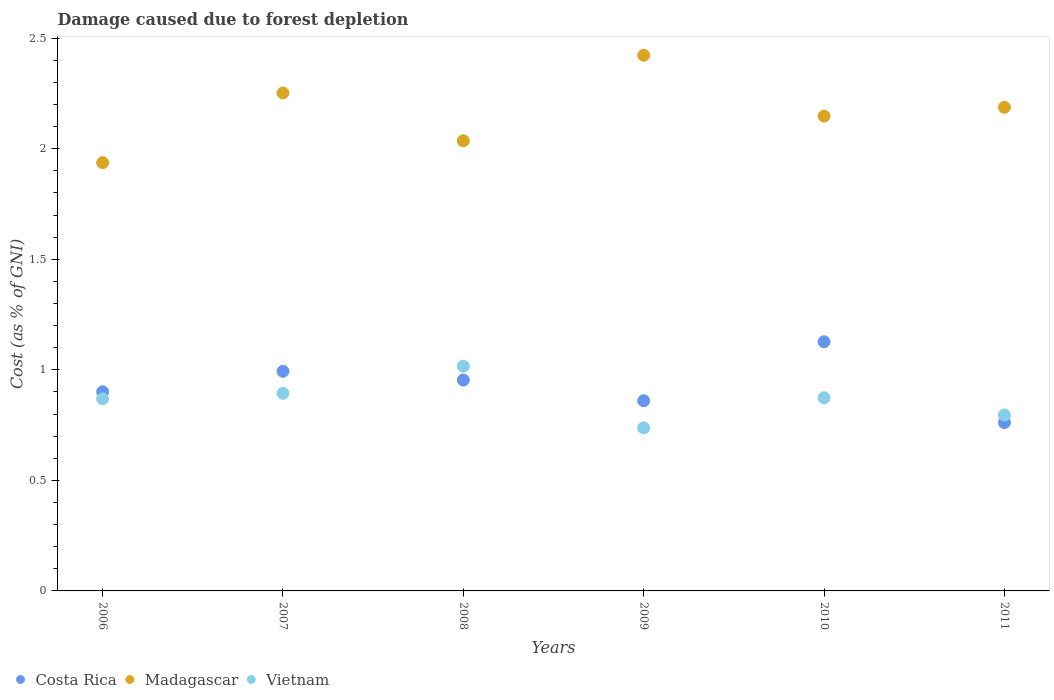Is the number of dotlines equal to the number of legend labels?
Ensure brevity in your answer.  Yes. What is the cost of damage caused due to forest depletion in Vietnam in 2011?
Your response must be concise. 0.8. Across all years, what is the maximum cost of damage caused due to forest depletion in Vietnam?
Provide a succinct answer. 1.02. Across all years, what is the minimum cost of damage caused due to forest depletion in Madagascar?
Provide a succinct answer. 1.94. In which year was the cost of damage caused due to forest depletion in Madagascar minimum?
Provide a short and direct response. 2006. What is the total cost of damage caused due to forest depletion in Costa Rica in the graph?
Provide a succinct answer. 5.6. What is the difference between the cost of damage caused due to forest depletion in Costa Rica in 2009 and that in 2011?
Your answer should be very brief. 0.1. What is the difference between the cost of damage caused due to forest depletion in Vietnam in 2006 and the cost of damage caused due to forest depletion in Costa Rica in 2010?
Ensure brevity in your answer.  -0.26. What is the average cost of damage caused due to forest depletion in Vietnam per year?
Give a very brief answer. 0.86. In the year 2006, what is the difference between the cost of damage caused due to forest depletion in Costa Rica and cost of damage caused due to forest depletion in Vietnam?
Give a very brief answer. 0.03. What is the ratio of the cost of damage caused due to forest depletion in Costa Rica in 2007 to that in 2011?
Offer a very short reply. 1.3. Is the difference between the cost of damage caused due to forest depletion in Costa Rica in 2007 and 2008 greater than the difference between the cost of damage caused due to forest depletion in Vietnam in 2007 and 2008?
Your answer should be very brief. Yes. What is the difference between the highest and the second highest cost of damage caused due to forest depletion in Madagascar?
Provide a short and direct response. 0.17. What is the difference between the highest and the lowest cost of damage caused due to forest depletion in Costa Rica?
Your response must be concise. 0.37. In how many years, is the cost of damage caused due to forest depletion in Madagascar greater than the average cost of damage caused due to forest depletion in Madagascar taken over all years?
Your answer should be compact. 3. Is the sum of the cost of damage caused due to forest depletion in Vietnam in 2007 and 2011 greater than the maximum cost of damage caused due to forest depletion in Madagascar across all years?
Offer a terse response. No. Is it the case that in every year, the sum of the cost of damage caused due to forest depletion in Madagascar and cost of damage caused due to forest depletion in Vietnam  is greater than the cost of damage caused due to forest depletion in Costa Rica?
Offer a very short reply. Yes. Is the cost of damage caused due to forest depletion in Vietnam strictly greater than the cost of damage caused due to forest depletion in Costa Rica over the years?
Offer a very short reply. No. How many years are there in the graph?
Provide a succinct answer. 6. Are the values on the major ticks of Y-axis written in scientific E-notation?
Ensure brevity in your answer.  No. Does the graph contain grids?
Offer a terse response. No. How many legend labels are there?
Ensure brevity in your answer.  3. How are the legend labels stacked?
Your response must be concise. Horizontal. What is the title of the graph?
Your response must be concise. Damage caused due to forest depletion. What is the label or title of the X-axis?
Provide a short and direct response. Years. What is the label or title of the Y-axis?
Give a very brief answer. Cost (as % of GNI). What is the Cost (as % of GNI) of Costa Rica in 2006?
Keep it short and to the point. 0.9. What is the Cost (as % of GNI) of Madagascar in 2006?
Ensure brevity in your answer.  1.94. What is the Cost (as % of GNI) in Vietnam in 2006?
Ensure brevity in your answer.  0.87. What is the Cost (as % of GNI) in Costa Rica in 2007?
Give a very brief answer. 0.99. What is the Cost (as % of GNI) of Madagascar in 2007?
Provide a succinct answer. 2.25. What is the Cost (as % of GNI) of Vietnam in 2007?
Ensure brevity in your answer.  0.89. What is the Cost (as % of GNI) of Costa Rica in 2008?
Provide a succinct answer. 0.95. What is the Cost (as % of GNI) in Madagascar in 2008?
Offer a terse response. 2.04. What is the Cost (as % of GNI) of Vietnam in 2008?
Offer a very short reply. 1.02. What is the Cost (as % of GNI) of Costa Rica in 2009?
Provide a short and direct response. 0.86. What is the Cost (as % of GNI) of Madagascar in 2009?
Provide a succinct answer. 2.42. What is the Cost (as % of GNI) of Vietnam in 2009?
Your response must be concise. 0.74. What is the Cost (as % of GNI) in Costa Rica in 2010?
Provide a succinct answer. 1.13. What is the Cost (as % of GNI) of Madagascar in 2010?
Provide a succinct answer. 2.15. What is the Cost (as % of GNI) of Vietnam in 2010?
Provide a short and direct response. 0.87. What is the Cost (as % of GNI) in Costa Rica in 2011?
Your response must be concise. 0.76. What is the Cost (as % of GNI) in Madagascar in 2011?
Give a very brief answer. 2.19. What is the Cost (as % of GNI) in Vietnam in 2011?
Give a very brief answer. 0.8. Across all years, what is the maximum Cost (as % of GNI) of Costa Rica?
Your answer should be very brief. 1.13. Across all years, what is the maximum Cost (as % of GNI) of Madagascar?
Your answer should be very brief. 2.42. Across all years, what is the maximum Cost (as % of GNI) in Vietnam?
Provide a short and direct response. 1.02. Across all years, what is the minimum Cost (as % of GNI) in Costa Rica?
Keep it short and to the point. 0.76. Across all years, what is the minimum Cost (as % of GNI) of Madagascar?
Offer a terse response. 1.94. Across all years, what is the minimum Cost (as % of GNI) of Vietnam?
Give a very brief answer. 0.74. What is the total Cost (as % of GNI) in Costa Rica in the graph?
Offer a terse response. 5.6. What is the total Cost (as % of GNI) in Madagascar in the graph?
Offer a very short reply. 12.98. What is the total Cost (as % of GNI) of Vietnam in the graph?
Your answer should be very brief. 5.19. What is the difference between the Cost (as % of GNI) of Costa Rica in 2006 and that in 2007?
Make the answer very short. -0.09. What is the difference between the Cost (as % of GNI) of Madagascar in 2006 and that in 2007?
Make the answer very short. -0.32. What is the difference between the Cost (as % of GNI) of Vietnam in 2006 and that in 2007?
Your answer should be compact. -0.03. What is the difference between the Cost (as % of GNI) in Costa Rica in 2006 and that in 2008?
Your response must be concise. -0.05. What is the difference between the Cost (as % of GNI) of Madagascar in 2006 and that in 2008?
Give a very brief answer. -0.1. What is the difference between the Cost (as % of GNI) in Vietnam in 2006 and that in 2008?
Give a very brief answer. -0.15. What is the difference between the Cost (as % of GNI) of Costa Rica in 2006 and that in 2009?
Give a very brief answer. 0.04. What is the difference between the Cost (as % of GNI) in Madagascar in 2006 and that in 2009?
Your answer should be very brief. -0.49. What is the difference between the Cost (as % of GNI) in Vietnam in 2006 and that in 2009?
Your answer should be very brief. 0.13. What is the difference between the Cost (as % of GNI) in Costa Rica in 2006 and that in 2010?
Offer a terse response. -0.23. What is the difference between the Cost (as % of GNI) in Madagascar in 2006 and that in 2010?
Offer a very short reply. -0.21. What is the difference between the Cost (as % of GNI) of Vietnam in 2006 and that in 2010?
Ensure brevity in your answer.  -0.01. What is the difference between the Cost (as % of GNI) of Costa Rica in 2006 and that in 2011?
Your answer should be very brief. 0.14. What is the difference between the Cost (as % of GNI) in Madagascar in 2006 and that in 2011?
Provide a succinct answer. -0.25. What is the difference between the Cost (as % of GNI) of Vietnam in 2006 and that in 2011?
Keep it short and to the point. 0.07. What is the difference between the Cost (as % of GNI) of Costa Rica in 2007 and that in 2008?
Provide a succinct answer. 0.04. What is the difference between the Cost (as % of GNI) of Madagascar in 2007 and that in 2008?
Your response must be concise. 0.22. What is the difference between the Cost (as % of GNI) in Vietnam in 2007 and that in 2008?
Provide a succinct answer. -0.12. What is the difference between the Cost (as % of GNI) in Costa Rica in 2007 and that in 2009?
Provide a succinct answer. 0.13. What is the difference between the Cost (as % of GNI) of Madagascar in 2007 and that in 2009?
Give a very brief answer. -0.17. What is the difference between the Cost (as % of GNI) in Vietnam in 2007 and that in 2009?
Your answer should be very brief. 0.16. What is the difference between the Cost (as % of GNI) in Costa Rica in 2007 and that in 2010?
Ensure brevity in your answer.  -0.13. What is the difference between the Cost (as % of GNI) in Madagascar in 2007 and that in 2010?
Your response must be concise. 0.11. What is the difference between the Cost (as % of GNI) in Vietnam in 2007 and that in 2010?
Your answer should be very brief. 0.02. What is the difference between the Cost (as % of GNI) of Costa Rica in 2007 and that in 2011?
Make the answer very short. 0.23. What is the difference between the Cost (as % of GNI) of Madagascar in 2007 and that in 2011?
Your answer should be very brief. 0.06. What is the difference between the Cost (as % of GNI) in Vietnam in 2007 and that in 2011?
Provide a succinct answer. 0.1. What is the difference between the Cost (as % of GNI) in Costa Rica in 2008 and that in 2009?
Make the answer very short. 0.09. What is the difference between the Cost (as % of GNI) of Madagascar in 2008 and that in 2009?
Your answer should be very brief. -0.39. What is the difference between the Cost (as % of GNI) of Vietnam in 2008 and that in 2009?
Keep it short and to the point. 0.28. What is the difference between the Cost (as % of GNI) in Costa Rica in 2008 and that in 2010?
Make the answer very short. -0.17. What is the difference between the Cost (as % of GNI) in Madagascar in 2008 and that in 2010?
Keep it short and to the point. -0.11. What is the difference between the Cost (as % of GNI) in Vietnam in 2008 and that in 2010?
Provide a succinct answer. 0.14. What is the difference between the Cost (as % of GNI) of Costa Rica in 2008 and that in 2011?
Your answer should be very brief. 0.19. What is the difference between the Cost (as % of GNI) in Madagascar in 2008 and that in 2011?
Your answer should be compact. -0.15. What is the difference between the Cost (as % of GNI) in Vietnam in 2008 and that in 2011?
Your response must be concise. 0.22. What is the difference between the Cost (as % of GNI) in Costa Rica in 2009 and that in 2010?
Offer a very short reply. -0.27. What is the difference between the Cost (as % of GNI) in Madagascar in 2009 and that in 2010?
Your answer should be very brief. 0.28. What is the difference between the Cost (as % of GNI) of Vietnam in 2009 and that in 2010?
Ensure brevity in your answer.  -0.14. What is the difference between the Cost (as % of GNI) of Costa Rica in 2009 and that in 2011?
Keep it short and to the point. 0.1. What is the difference between the Cost (as % of GNI) in Madagascar in 2009 and that in 2011?
Offer a very short reply. 0.24. What is the difference between the Cost (as % of GNI) in Vietnam in 2009 and that in 2011?
Your response must be concise. -0.06. What is the difference between the Cost (as % of GNI) of Costa Rica in 2010 and that in 2011?
Make the answer very short. 0.37. What is the difference between the Cost (as % of GNI) in Madagascar in 2010 and that in 2011?
Your answer should be very brief. -0.04. What is the difference between the Cost (as % of GNI) in Vietnam in 2010 and that in 2011?
Provide a succinct answer. 0.08. What is the difference between the Cost (as % of GNI) of Costa Rica in 2006 and the Cost (as % of GNI) of Madagascar in 2007?
Keep it short and to the point. -1.35. What is the difference between the Cost (as % of GNI) of Costa Rica in 2006 and the Cost (as % of GNI) of Vietnam in 2007?
Offer a very short reply. 0.01. What is the difference between the Cost (as % of GNI) in Madagascar in 2006 and the Cost (as % of GNI) in Vietnam in 2007?
Keep it short and to the point. 1.04. What is the difference between the Cost (as % of GNI) of Costa Rica in 2006 and the Cost (as % of GNI) of Madagascar in 2008?
Provide a succinct answer. -1.14. What is the difference between the Cost (as % of GNI) of Costa Rica in 2006 and the Cost (as % of GNI) of Vietnam in 2008?
Offer a terse response. -0.12. What is the difference between the Cost (as % of GNI) in Madagascar in 2006 and the Cost (as % of GNI) in Vietnam in 2008?
Offer a very short reply. 0.92. What is the difference between the Cost (as % of GNI) in Costa Rica in 2006 and the Cost (as % of GNI) in Madagascar in 2009?
Ensure brevity in your answer.  -1.52. What is the difference between the Cost (as % of GNI) in Costa Rica in 2006 and the Cost (as % of GNI) in Vietnam in 2009?
Your answer should be compact. 0.16. What is the difference between the Cost (as % of GNI) of Madagascar in 2006 and the Cost (as % of GNI) of Vietnam in 2009?
Ensure brevity in your answer.  1.2. What is the difference between the Cost (as % of GNI) of Costa Rica in 2006 and the Cost (as % of GNI) of Madagascar in 2010?
Keep it short and to the point. -1.25. What is the difference between the Cost (as % of GNI) of Costa Rica in 2006 and the Cost (as % of GNI) of Vietnam in 2010?
Provide a short and direct response. 0.03. What is the difference between the Cost (as % of GNI) of Madagascar in 2006 and the Cost (as % of GNI) of Vietnam in 2010?
Make the answer very short. 1.06. What is the difference between the Cost (as % of GNI) in Costa Rica in 2006 and the Cost (as % of GNI) in Madagascar in 2011?
Your answer should be very brief. -1.29. What is the difference between the Cost (as % of GNI) of Costa Rica in 2006 and the Cost (as % of GNI) of Vietnam in 2011?
Provide a succinct answer. 0.1. What is the difference between the Cost (as % of GNI) of Madagascar in 2006 and the Cost (as % of GNI) of Vietnam in 2011?
Offer a terse response. 1.14. What is the difference between the Cost (as % of GNI) of Costa Rica in 2007 and the Cost (as % of GNI) of Madagascar in 2008?
Provide a succinct answer. -1.04. What is the difference between the Cost (as % of GNI) of Costa Rica in 2007 and the Cost (as % of GNI) of Vietnam in 2008?
Provide a succinct answer. -0.02. What is the difference between the Cost (as % of GNI) in Madagascar in 2007 and the Cost (as % of GNI) in Vietnam in 2008?
Provide a short and direct response. 1.24. What is the difference between the Cost (as % of GNI) in Costa Rica in 2007 and the Cost (as % of GNI) in Madagascar in 2009?
Provide a short and direct response. -1.43. What is the difference between the Cost (as % of GNI) of Costa Rica in 2007 and the Cost (as % of GNI) of Vietnam in 2009?
Keep it short and to the point. 0.26. What is the difference between the Cost (as % of GNI) of Madagascar in 2007 and the Cost (as % of GNI) of Vietnam in 2009?
Make the answer very short. 1.51. What is the difference between the Cost (as % of GNI) in Costa Rica in 2007 and the Cost (as % of GNI) in Madagascar in 2010?
Make the answer very short. -1.15. What is the difference between the Cost (as % of GNI) in Costa Rica in 2007 and the Cost (as % of GNI) in Vietnam in 2010?
Your answer should be very brief. 0.12. What is the difference between the Cost (as % of GNI) in Madagascar in 2007 and the Cost (as % of GNI) in Vietnam in 2010?
Keep it short and to the point. 1.38. What is the difference between the Cost (as % of GNI) in Costa Rica in 2007 and the Cost (as % of GNI) in Madagascar in 2011?
Keep it short and to the point. -1.19. What is the difference between the Cost (as % of GNI) in Costa Rica in 2007 and the Cost (as % of GNI) in Vietnam in 2011?
Give a very brief answer. 0.2. What is the difference between the Cost (as % of GNI) of Madagascar in 2007 and the Cost (as % of GNI) of Vietnam in 2011?
Give a very brief answer. 1.46. What is the difference between the Cost (as % of GNI) of Costa Rica in 2008 and the Cost (as % of GNI) of Madagascar in 2009?
Keep it short and to the point. -1.47. What is the difference between the Cost (as % of GNI) in Costa Rica in 2008 and the Cost (as % of GNI) in Vietnam in 2009?
Keep it short and to the point. 0.22. What is the difference between the Cost (as % of GNI) of Madagascar in 2008 and the Cost (as % of GNI) of Vietnam in 2009?
Keep it short and to the point. 1.3. What is the difference between the Cost (as % of GNI) in Costa Rica in 2008 and the Cost (as % of GNI) in Madagascar in 2010?
Ensure brevity in your answer.  -1.19. What is the difference between the Cost (as % of GNI) of Costa Rica in 2008 and the Cost (as % of GNI) of Vietnam in 2010?
Your answer should be compact. 0.08. What is the difference between the Cost (as % of GNI) in Madagascar in 2008 and the Cost (as % of GNI) in Vietnam in 2010?
Your answer should be compact. 1.16. What is the difference between the Cost (as % of GNI) of Costa Rica in 2008 and the Cost (as % of GNI) of Madagascar in 2011?
Your answer should be compact. -1.23. What is the difference between the Cost (as % of GNI) of Costa Rica in 2008 and the Cost (as % of GNI) of Vietnam in 2011?
Provide a short and direct response. 0.16. What is the difference between the Cost (as % of GNI) in Madagascar in 2008 and the Cost (as % of GNI) in Vietnam in 2011?
Keep it short and to the point. 1.24. What is the difference between the Cost (as % of GNI) of Costa Rica in 2009 and the Cost (as % of GNI) of Madagascar in 2010?
Make the answer very short. -1.29. What is the difference between the Cost (as % of GNI) of Costa Rica in 2009 and the Cost (as % of GNI) of Vietnam in 2010?
Provide a succinct answer. -0.01. What is the difference between the Cost (as % of GNI) of Madagascar in 2009 and the Cost (as % of GNI) of Vietnam in 2010?
Your answer should be compact. 1.55. What is the difference between the Cost (as % of GNI) in Costa Rica in 2009 and the Cost (as % of GNI) in Madagascar in 2011?
Your answer should be very brief. -1.33. What is the difference between the Cost (as % of GNI) in Costa Rica in 2009 and the Cost (as % of GNI) in Vietnam in 2011?
Provide a succinct answer. 0.06. What is the difference between the Cost (as % of GNI) of Madagascar in 2009 and the Cost (as % of GNI) of Vietnam in 2011?
Your answer should be compact. 1.63. What is the difference between the Cost (as % of GNI) of Costa Rica in 2010 and the Cost (as % of GNI) of Madagascar in 2011?
Your answer should be compact. -1.06. What is the difference between the Cost (as % of GNI) in Costa Rica in 2010 and the Cost (as % of GNI) in Vietnam in 2011?
Give a very brief answer. 0.33. What is the difference between the Cost (as % of GNI) in Madagascar in 2010 and the Cost (as % of GNI) in Vietnam in 2011?
Ensure brevity in your answer.  1.35. What is the average Cost (as % of GNI) in Costa Rica per year?
Provide a short and direct response. 0.93. What is the average Cost (as % of GNI) in Madagascar per year?
Provide a succinct answer. 2.16. What is the average Cost (as % of GNI) of Vietnam per year?
Offer a very short reply. 0.86. In the year 2006, what is the difference between the Cost (as % of GNI) of Costa Rica and Cost (as % of GNI) of Madagascar?
Provide a short and direct response. -1.04. In the year 2006, what is the difference between the Cost (as % of GNI) in Costa Rica and Cost (as % of GNI) in Vietnam?
Provide a short and direct response. 0.03. In the year 2006, what is the difference between the Cost (as % of GNI) in Madagascar and Cost (as % of GNI) in Vietnam?
Offer a terse response. 1.07. In the year 2007, what is the difference between the Cost (as % of GNI) in Costa Rica and Cost (as % of GNI) in Madagascar?
Your response must be concise. -1.26. In the year 2007, what is the difference between the Cost (as % of GNI) in Costa Rica and Cost (as % of GNI) in Vietnam?
Your answer should be compact. 0.1. In the year 2007, what is the difference between the Cost (as % of GNI) of Madagascar and Cost (as % of GNI) of Vietnam?
Your answer should be compact. 1.36. In the year 2008, what is the difference between the Cost (as % of GNI) in Costa Rica and Cost (as % of GNI) in Madagascar?
Keep it short and to the point. -1.08. In the year 2008, what is the difference between the Cost (as % of GNI) in Costa Rica and Cost (as % of GNI) in Vietnam?
Your answer should be compact. -0.06. In the year 2008, what is the difference between the Cost (as % of GNI) of Madagascar and Cost (as % of GNI) of Vietnam?
Give a very brief answer. 1.02. In the year 2009, what is the difference between the Cost (as % of GNI) of Costa Rica and Cost (as % of GNI) of Madagascar?
Your answer should be compact. -1.56. In the year 2009, what is the difference between the Cost (as % of GNI) in Costa Rica and Cost (as % of GNI) in Vietnam?
Offer a very short reply. 0.12. In the year 2009, what is the difference between the Cost (as % of GNI) of Madagascar and Cost (as % of GNI) of Vietnam?
Provide a succinct answer. 1.69. In the year 2010, what is the difference between the Cost (as % of GNI) of Costa Rica and Cost (as % of GNI) of Madagascar?
Your answer should be very brief. -1.02. In the year 2010, what is the difference between the Cost (as % of GNI) of Costa Rica and Cost (as % of GNI) of Vietnam?
Provide a succinct answer. 0.25. In the year 2010, what is the difference between the Cost (as % of GNI) in Madagascar and Cost (as % of GNI) in Vietnam?
Make the answer very short. 1.27. In the year 2011, what is the difference between the Cost (as % of GNI) of Costa Rica and Cost (as % of GNI) of Madagascar?
Your response must be concise. -1.43. In the year 2011, what is the difference between the Cost (as % of GNI) of Costa Rica and Cost (as % of GNI) of Vietnam?
Give a very brief answer. -0.03. In the year 2011, what is the difference between the Cost (as % of GNI) of Madagascar and Cost (as % of GNI) of Vietnam?
Provide a succinct answer. 1.39. What is the ratio of the Cost (as % of GNI) in Costa Rica in 2006 to that in 2007?
Ensure brevity in your answer.  0.91. What is the ratio of the Cost (as % of GNI) of Madagascar in 2006 to that in 2007?
Your answer should be compact. 0.86. What is the ratio of the Cost (as % of GNI) in Vietnam in 2006 to that in 2007?
Offer a very short reply. 0.97. What is the ratio of the Cost (as % of GNI) of Costa Rica in 2006 to that in 2008?
Keep it short and to the point. 0.94. What is the ratio of the Cost (as % of GNI) in Madagascar in 2006 to that in 2008?
Keep it short and to the point. 0.95. What is the ratio of the Cost (as % of GNI) of Vietnam in 2006 to that in 2008?
Your answer should be compact. 0.85. What is the ratio of the Cost (as % of GNI) in Costa Rica in 2006 to that in 2009?
Offer a terse response. 1.05. What is the ratio of the Cost (as % of GNI) in Madagascar in 2006 to that in 2009?
Provide a succinct answer. 0.8. What is the ratio of the Cost (as % of GNI) of Vietnam in 2006 to that in 2009?
Provide a succinct answer. 1.18. What is the ratio of the Cost (as % of GNI) of Costa Rica in 2006 to that in 2010?
Provide a succinct answer. 0.8. What is the ratio of the Cost (as % of GNI) in Madagascar in 2006 to that in 2010?
Ensure brevity in your answer.  0.9. What is the ratio of the Cost (as % of GNI) of Vietnam in 2006 to that in 2010?
Give a very brief answer. 0.99. What is the ratio of the Cost (as % of GNI) of Costa Rica in 2006 to that in 2011?
Ensure brevity in your answer.  1.18. What is the ratio of the Cost (as % of GNI) in Madagascar in 2006 to that in 2011?
Your answer should be very brief. 0.89. What is the ratio of the Cost (as % of GNI) of Vietnam in 2006 to that in 2011?
Ensure brevity in your answer.  1.09. What is the ratio of the Cost (as % of GNI) of Costa Rica in 2007 to that in 2008?
Ensure brevity in your answer.  1.04. What is the ratio of the Cost (as % of GNI) of Madagascar in 2007 to that in 2008?
Keep it short and to the point. 1.11. What is the ratio of the Cost (as % of GNI) in Vietnam in 2007 to that in 2008?
Give a very brief answer. 0.88. What is the ratio of the Cost (as % of GNI) in Costa Rica in 2007 to that in 2009?
Your answer should be compact. 1.15. What is the ratio of the Cost (as % of GNI) in Madagascar in 2007 to that in 2009?
Offer a terse response. 0.93. What is the ratio of the Cost (as % of GNI) in Vietnam in 2007 to that in 2009?
Ensure brevity in your answer.  1.21. What is the ratio of the Cost (as % of GNI) in Costa Rica in 2007 to that in 2010?
Your answer should be compact. 0.88. What is the ratio of the Cost (as % of GNI) of Madagascar in 2007 to that in 2010?
Your answer should be compact. 1.05. What is the ratio of the Cost (as % of GNI) of Vietnam in 2007 to that in 2010?
Your answer should be compact. 1.02. What is the ratio of the Cost (as % of GNI) in Costa Rica in 2007 to that in 2011?
Keep it short and to the point. 1.3. What is the ratio of the Cost (as % of GNI) in Madagascar in 2007 to that in 2011?
Offer a terse response. 1.03. What is the ratio of the Cost (as % of GNI) in Vietnam in 2007 to that in 2011?
Provide a short and direct response. 1.12. What is the ratio of the Cost (as % of GNI) in Costa Rica in 2008 to that in 2009?
Provide a succinct answer. 1.11. What is the ratio of the Cost (as % of GNI) in Madagascar in 2008 to that in 2009?
Your answer should be very brief. 0.84. What is the ratio of the Cost (as % of GNI) of Vietnam in 2008 to that in 2009?
Provide a succinct answer. 1.38. What is the ratio of the Cost (as % of GNI) in Costa Rica in 2008 to that in 2010?
Offer a very short reply. 0.85. What is the ratio of the Cost (as % of GNI) of Madagascar in 2008 to that in 2010?
Offer a terse response. 0.95. What is the ratio of the Cost (as % of GNI) of Vietnam in 2008 to that in 2010?
Provide a succinct answer. 1.16. What is the ratio of the Cost (as % of GNI) in Costa Rica in 2008 to that in 2011?
Provide a short and direct response. 1.25. What is the ratio of the Cost (as % of GNI) in Madagascar in 2008 to that in 2011?
Keep it short and to the point. 0.93. What is the ratio of the Cost (as % of GNI) in Vietnam in 2008 to that in 2011?
Your response must be concise. 1.28. What is the ratio of the Cost (as % of GNI) in Costa Rica in 2009 to that in 2010?
Your response must be concise. 0.76. What is the ratio of the Cost (as % of GNI) of Madagascar in 2009 to that in 2010?
Your answer should be very brief. 1.13. What is the ratio of the Cost (as % of GNI) of Vietnam in 2009 to that in 2010?
Provide a short and direct response. 0.84. What is the ratio of the Cost (as % of GNI) in Costa Rica in 2009 to that in 2011?
Your answer should be compact. 1.13. What is the ratio of the Cost (as % of GNI) in Madagascar in 2009 to that in 2011?
Your answer should be very brief. 1.11. What is the ratio of the Cost (as % of GNI) of Vietnam in 2009 to that in 2011?
Ensure brevity in your answer.  0.93. What is the ratio of the Cost (as % of GNI) of Costa Rica in 2010 to that in 2011?
Ensure brevity in your answer.  1.48. What is the ratio of the Cost (as % of GNI) in Madagascar in 2010 to that in 2011?
Your response must be concise. 0.98. What is the ratio of the Cost (as % of GNI) in Vietnam in 2010 to that in 2011?
Provide a short and direct response. 1.1. What is the difference between the highest and the second highest Cost (as % of GNI) in Costa Rica?
Provide a short and direct response. 0.13. What is the difference between the highest and the second highest Cost (as % of GNI) in Madagascar?
Give a very brief answer. 0.17. What is the difference between the highest and the second highest Cost (as % of GNI) of Vietnam?
Make the answer very short. 0.12. What is the difference between the highest and the lowest Cost (as % of GNI) in Costa Rica?
Keep it short and to the point. 0.37. What is the difference between the highest and the lowest Cost (as % of GNI) of Madagascar?
Provide a succinct answer. 0.49. What is the difference between the highest and the lowest Cost (as % of GNI) in Vietnam?
Your answer should be very brief. 0.28. 